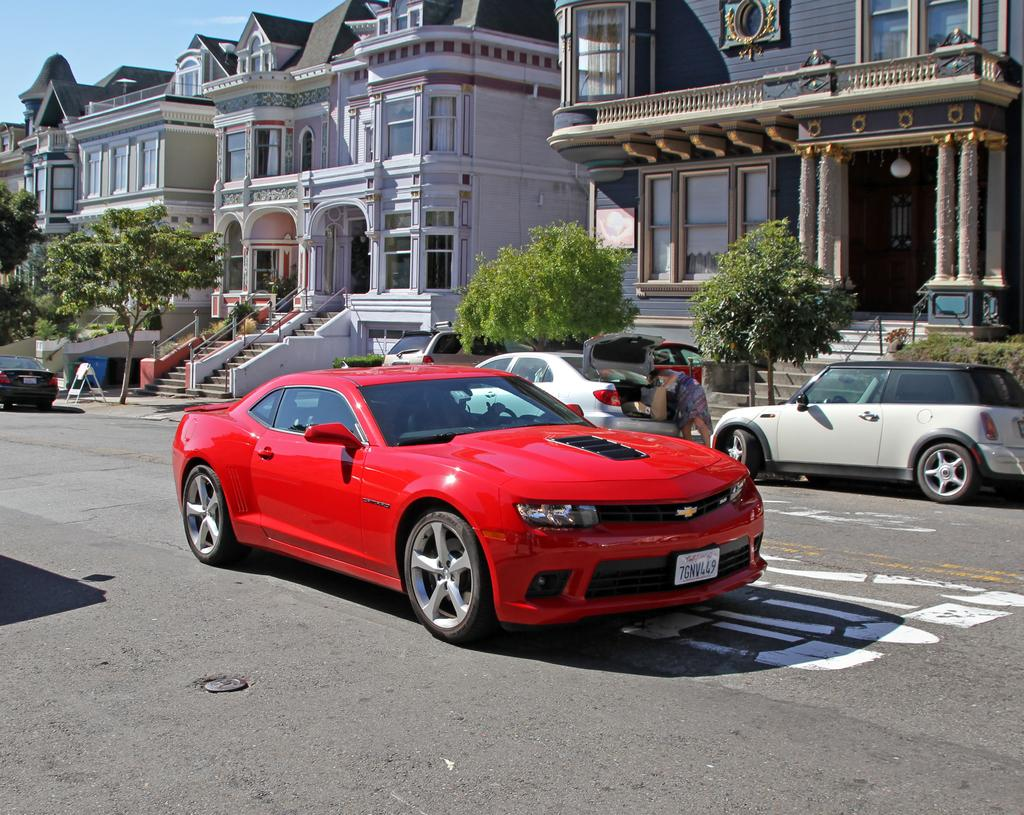What is present on the road in the image? There are vehicles on the road in the image. What can be seen behind the vehicles? There are trees behind the vehicles. What is located behind the trees? There are buildings behind the trees. What is visible in the background of the image? The sky is visible behind the buildings. Who is the owner of the tent in the image? There is no tent present in the image. 